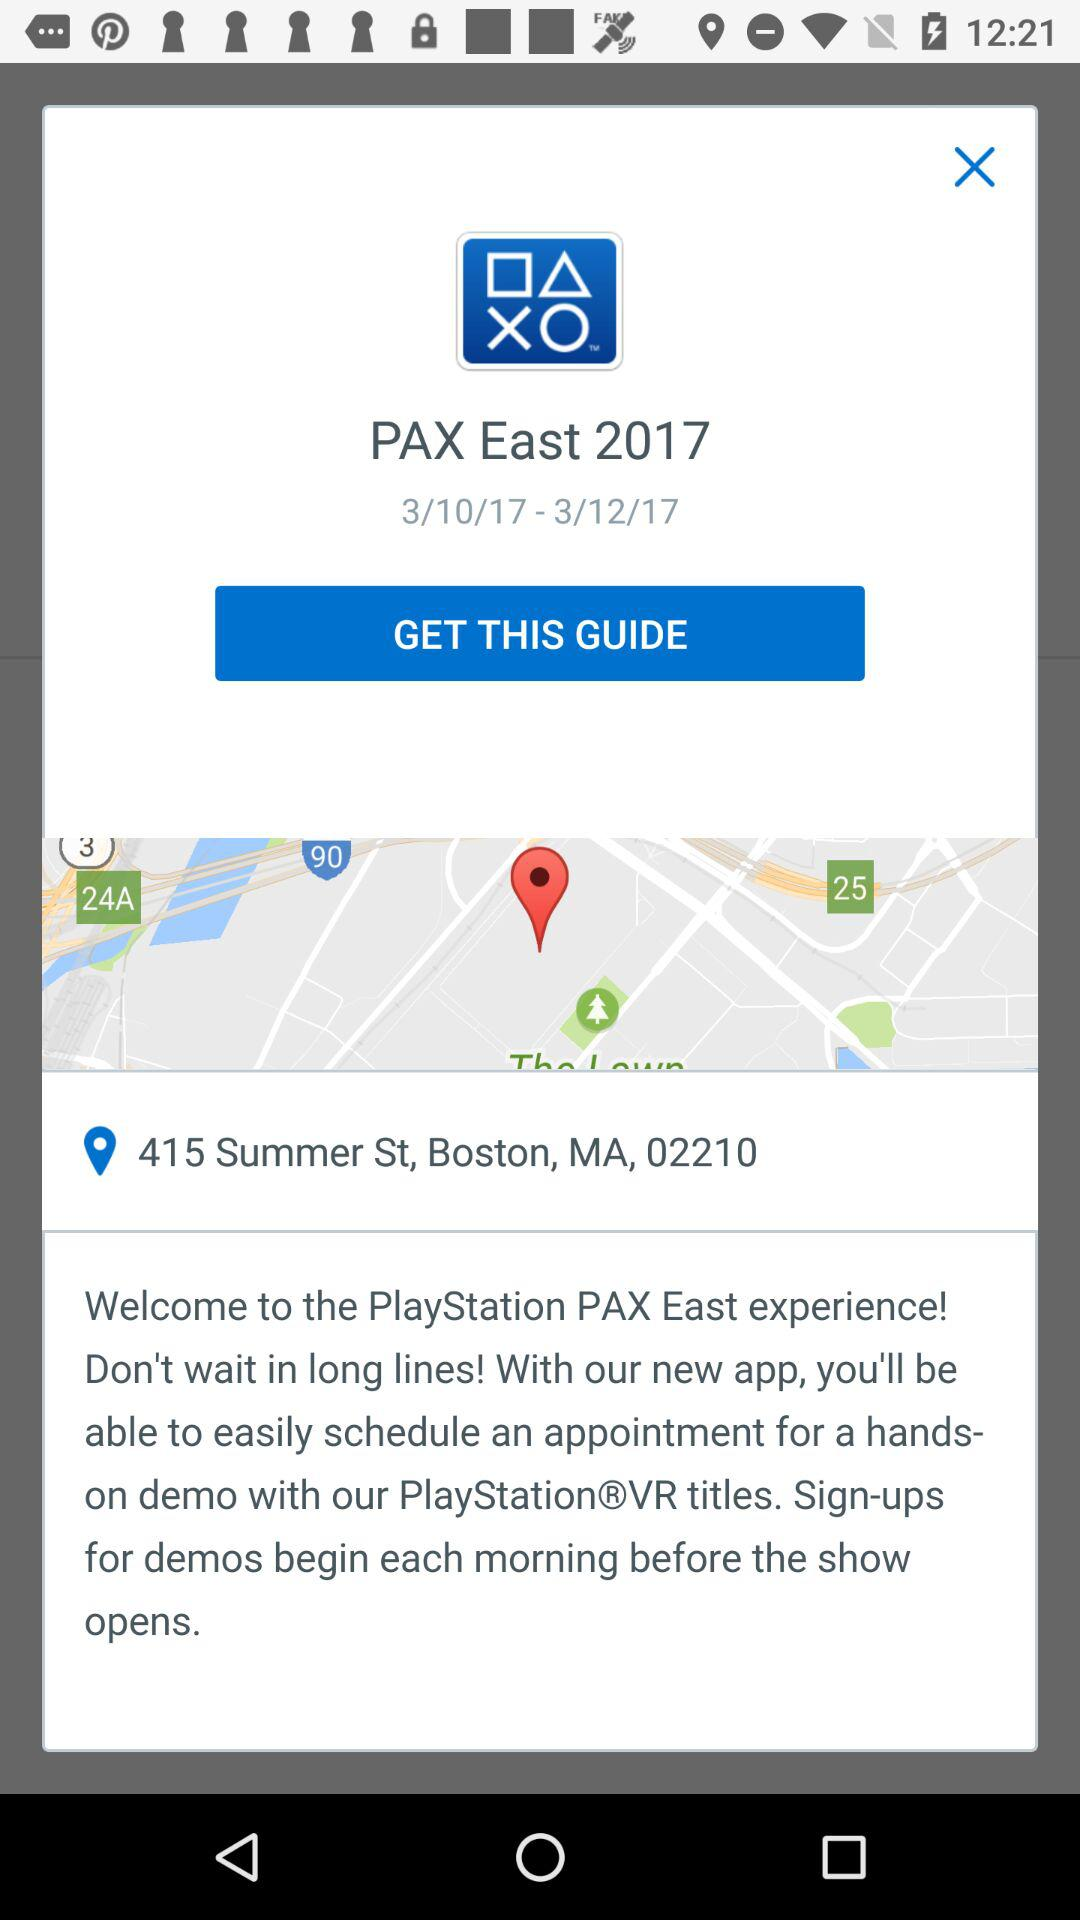What address is shown on the screen? The shown address is 415 Summer St, Boston, MA, 02210. 